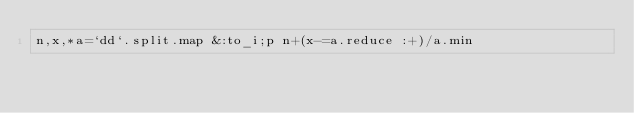Convert code to text. <code><loc_0><loc_0><loc_500><loc_500><_Ruby_>n,x,*a=`dd`.split.map &:to_i;p n+(x-=a.reduce :+)/a.min</code> 